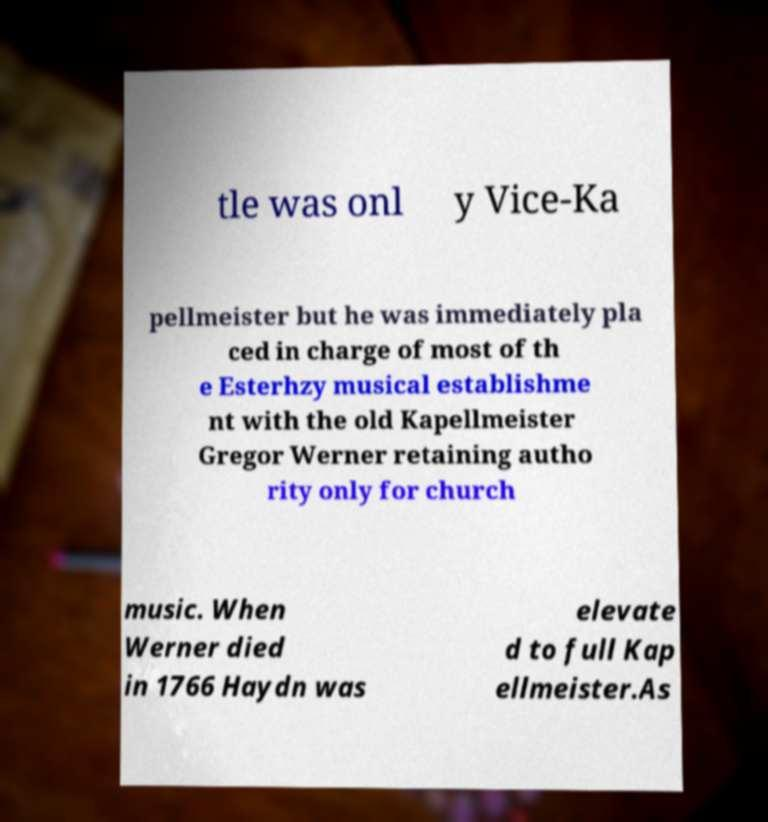Could you assist in decoding the text presented in this image and type it out clearly? tle was onl y Vice-Ka pellmeister but he was immediately pla ced in charge of most of th e Esterhzy musical establishme nt with the old Kapellmeister Gregor Werner retaining autho rity only for church music. When Werner died in 1766 Haydn was elevate d to full Kap ellmeister.As 